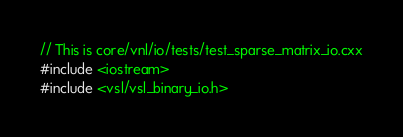Convert code to text. <code><loc_0><loc_0><loc_500><loc_500><_C++_>// This is core/vnl/io/tests/test_sparse_matrix_io.cxx
#include <iostream>
#include <vsl/vsl_binary_io.h></code> 